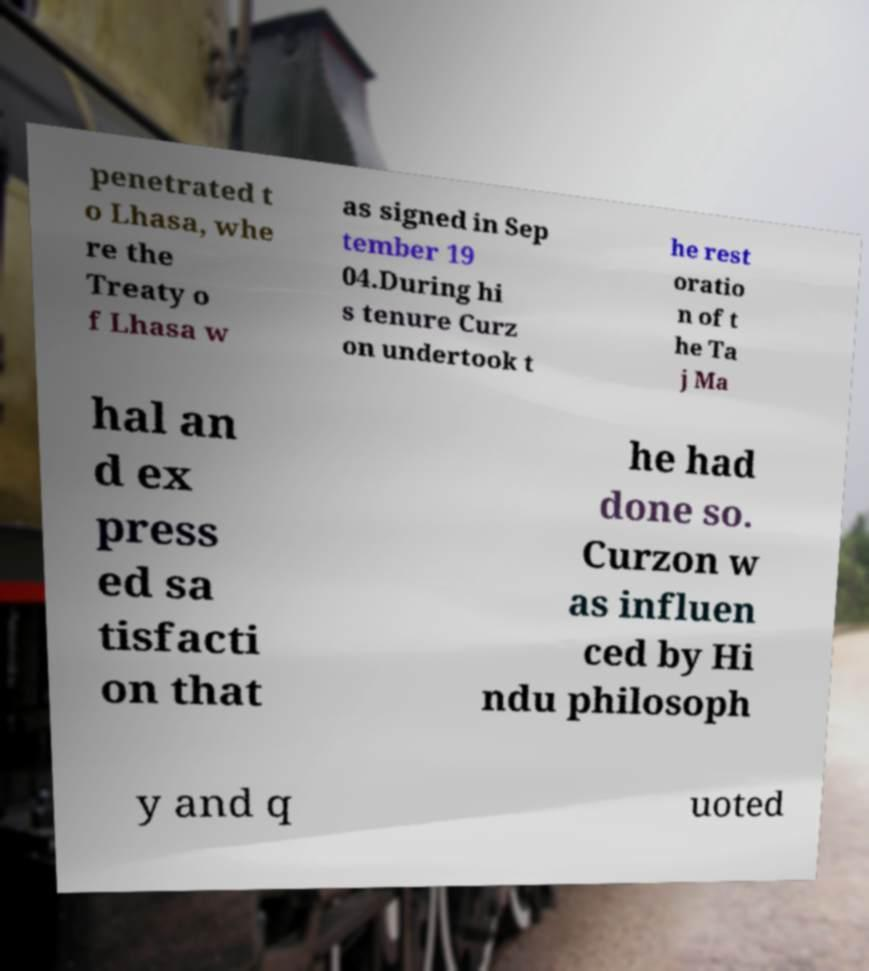I need the written content from this picture converted into text. Can you do that? penetrated t o Lhasa, whe re the Treaty o f Lhasa w as signed in Sep tember 19 04.During hi s tenure Curz on undertook t he rest oratio n of t he Ta j Ma hal an d ex press ed sa tisfacti on that he had done so. Curzon w as influen ced by Hi ndu philosoph y and q uoted 